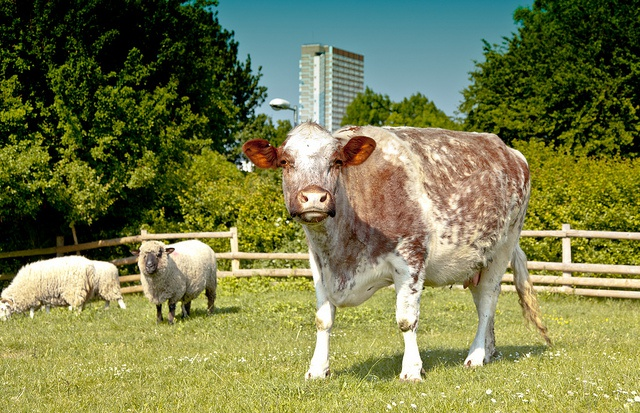Describe the objects in this image and their specific colors. I can see cow in darkgreen, tan, ivory, gray, and darkgray tones, sheep in darkgreen, gray, ivory, and tan tones, sheep in darkgreen, beige, khaki, and tan tones, and sheep in darkgreen, tan, and beige tones in this image. 